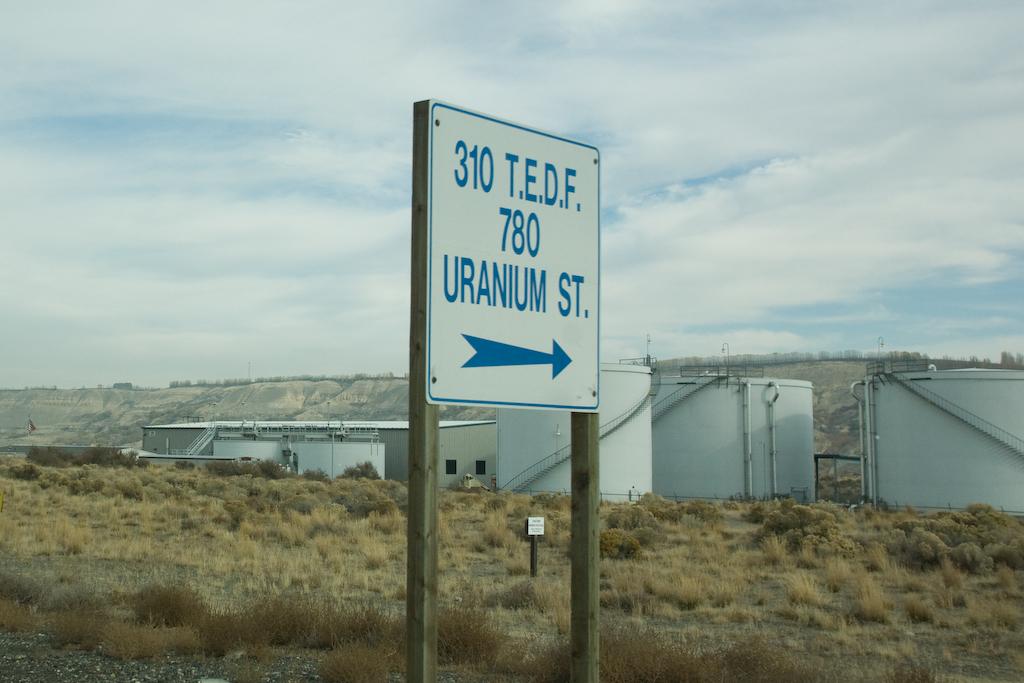What is the name of the street to the right?
Provide a succinct answer. Uranium st. 